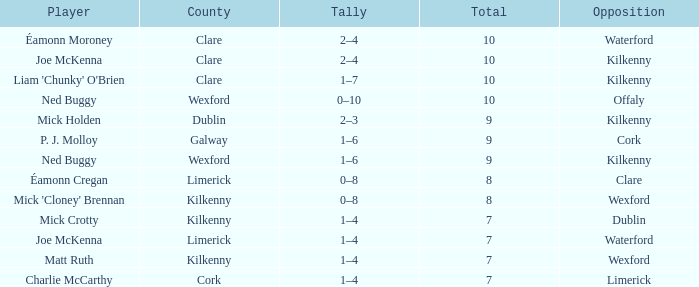Which County has a Rank larger than 8, and a Player of joe mckenna? Limerick. 